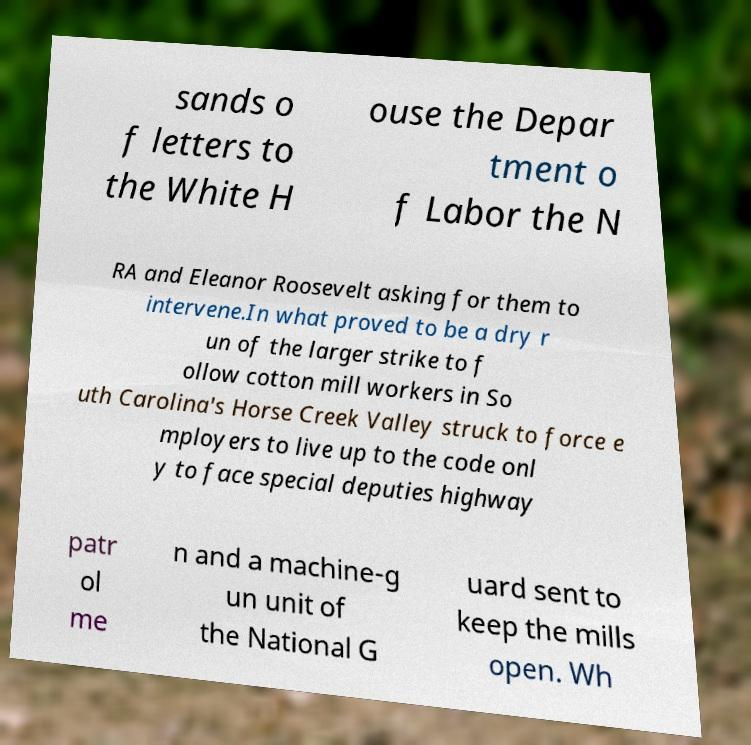Please identify and transcribe the text found in this image. sands o f letters to the White H ouse the Depar tment o f Labor the N RA and Eleanor Roosevelt asking for them to intervene.In what proved to be a dry r un of the larger strike to f ollow cotton mill workers in So uth Carolina's Horse Creek Valley struck to force e mployers to live up to the code onl y to face special deputies highway patr ol me n and a machine-g un unit of the National G uard sent to keep the mills open. Wh 